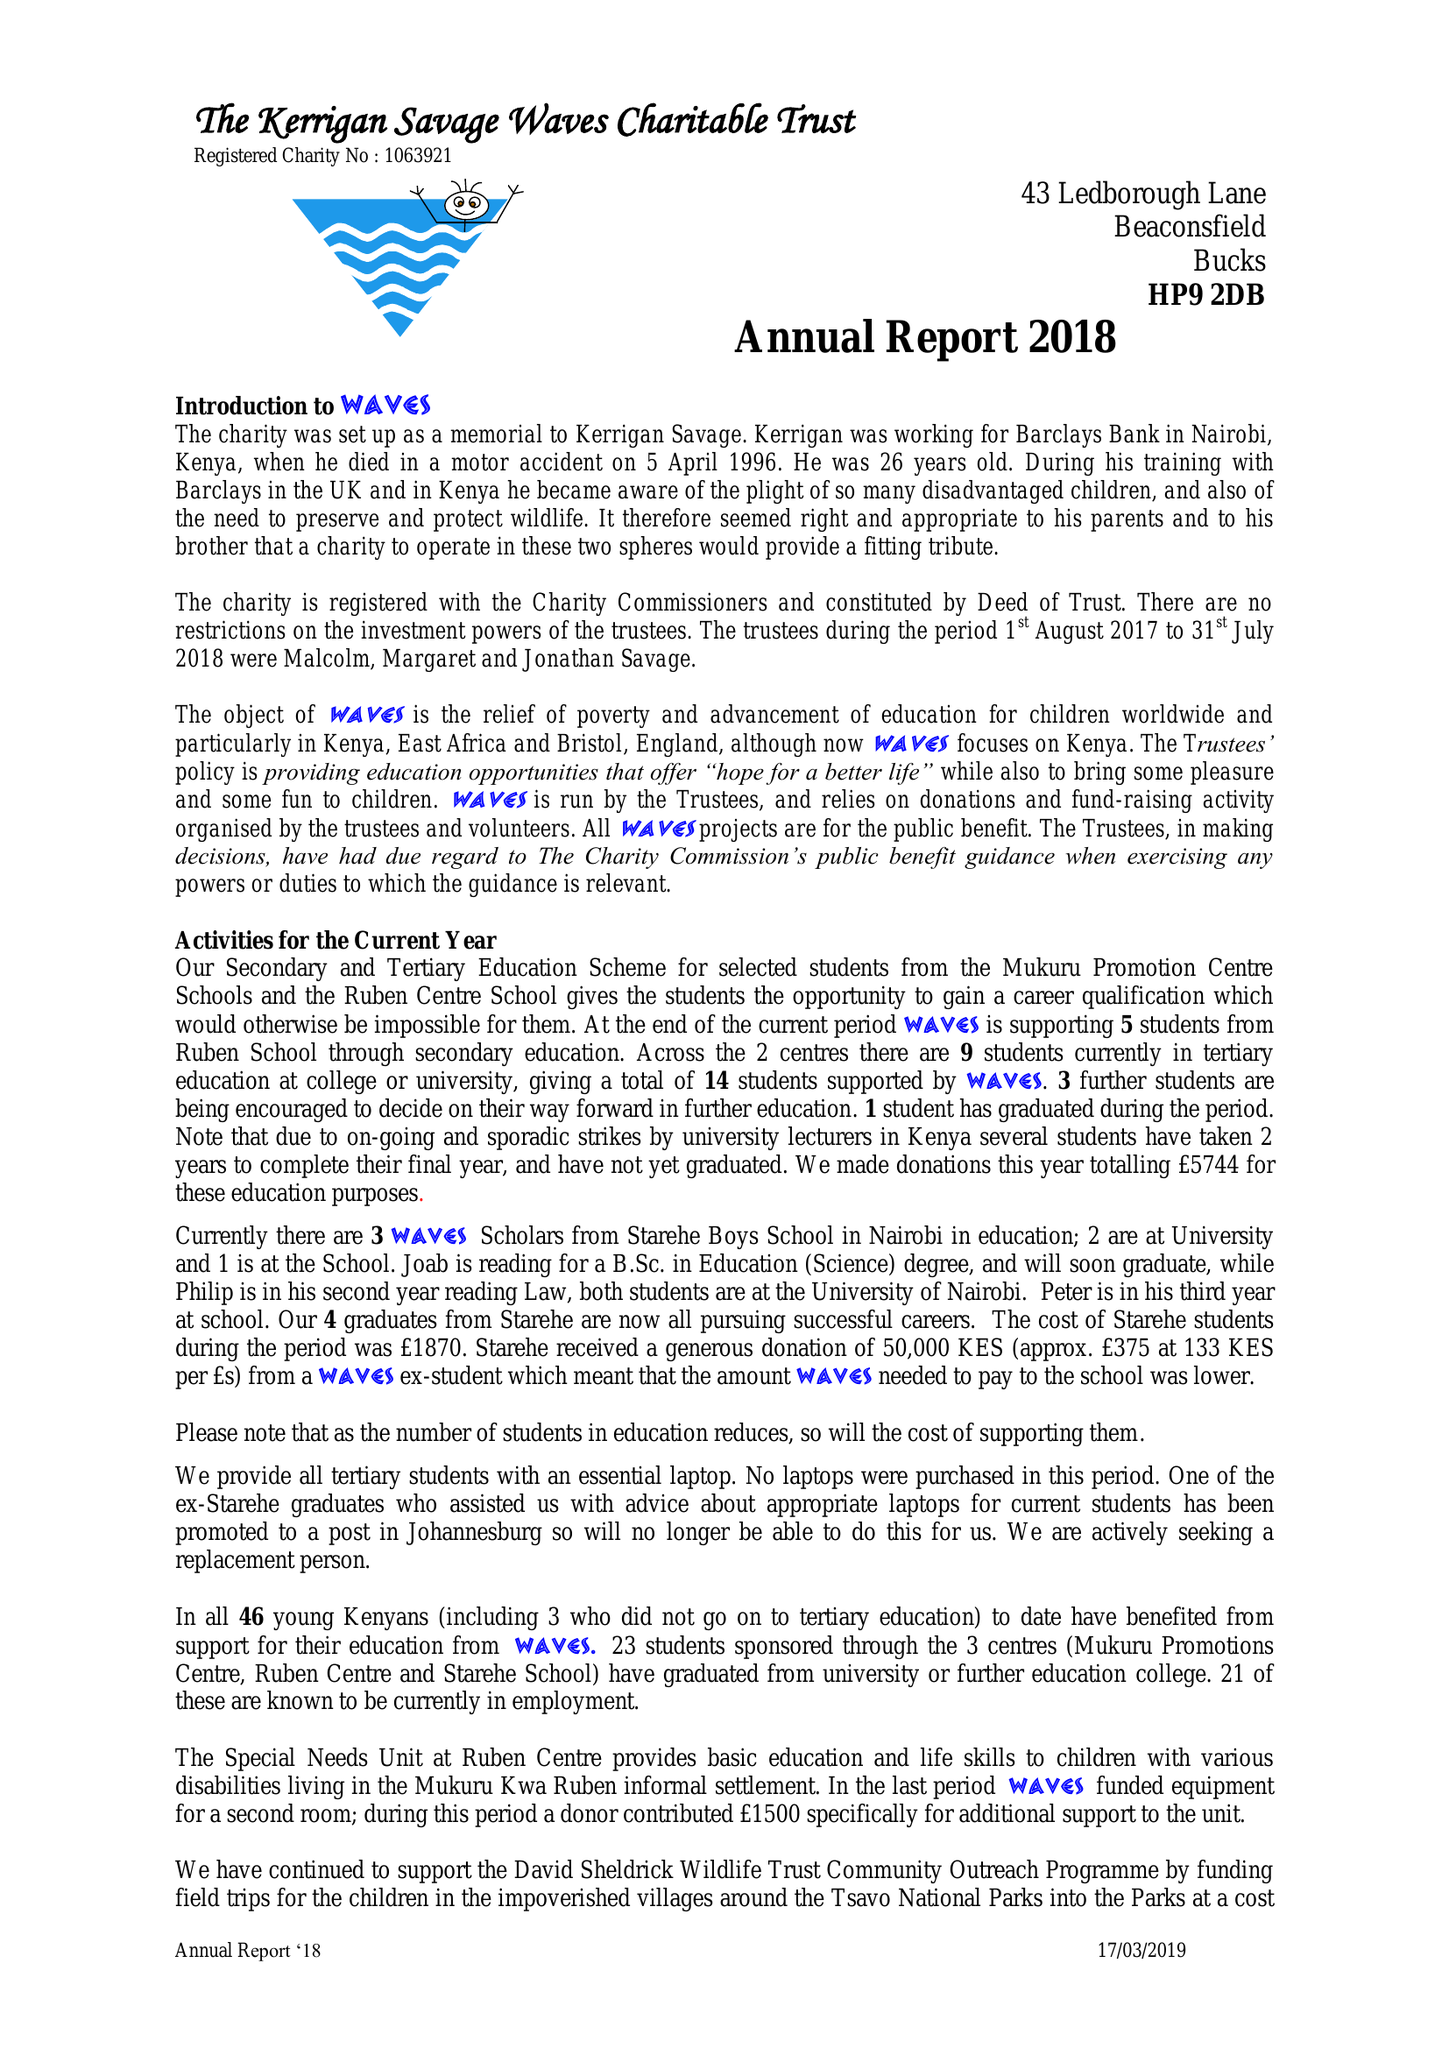What is the value for the income_annually_in_british_pounds?
Answer the question using a single word or phrase. 33913.00 